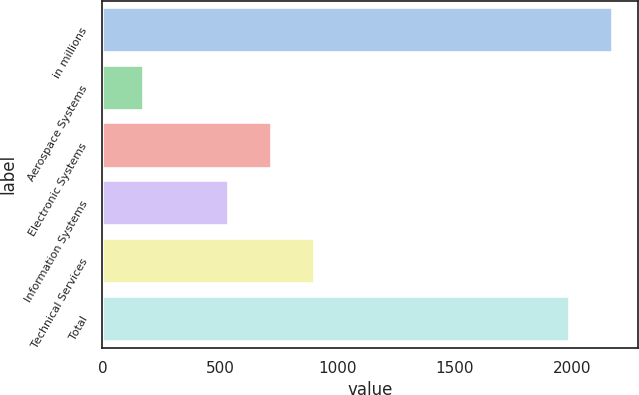Convert chart to OTSL. <chart><loc_0><loc_0><loc_500><loc_500><bar_chart><fcel>in millions<fcel>Aerospace Systems<fcel>Electronic Systems<fcel>Information Systems<fcel>Technical Services<fcel>Total<nl><fcel>2173.8<fcel>176<fcel>720.8<fcel>537<fcel>904.6<fcel>1990<nl></chart> 